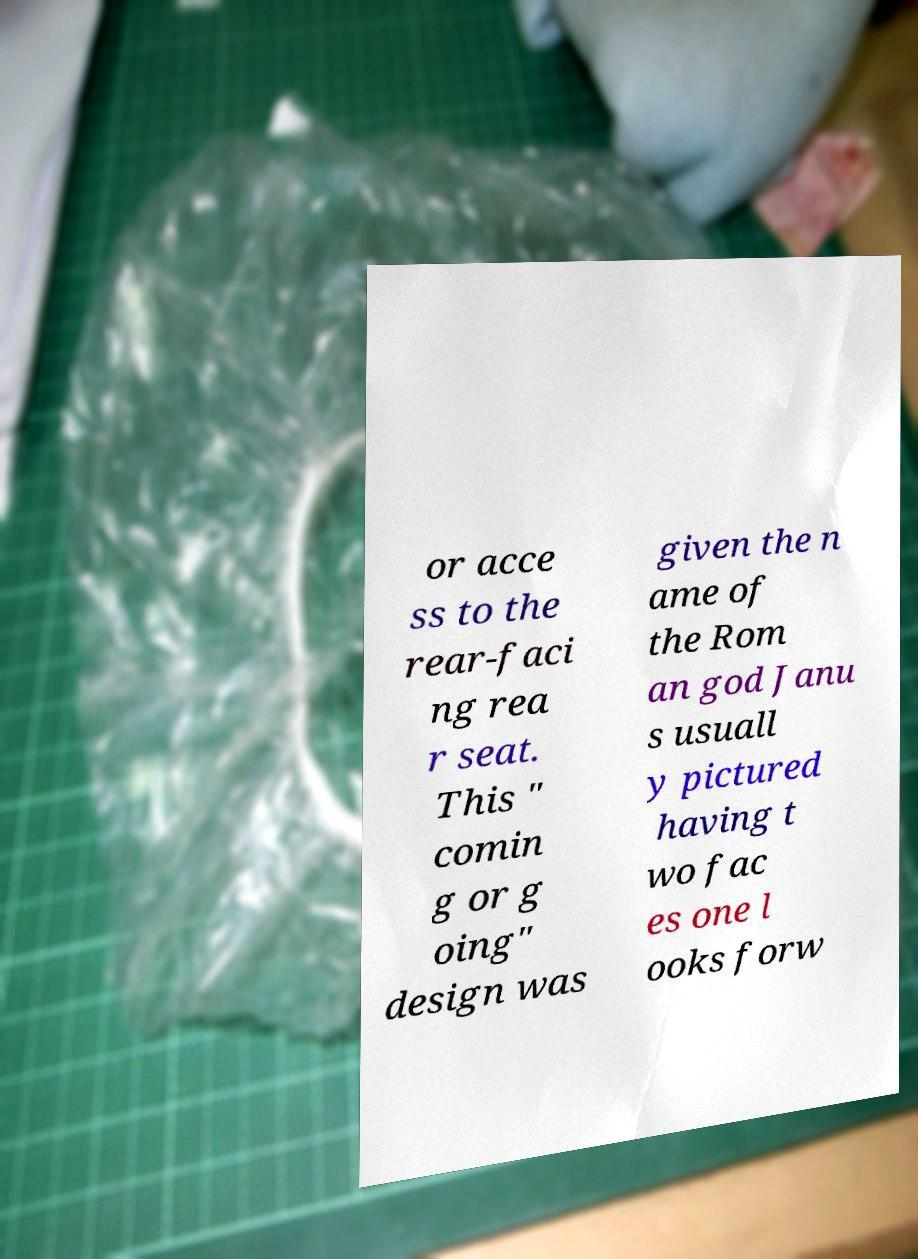Please read and relay the text visible in this image. What does it say? or acce ss to the rear-faci ng rea r seat. This " comin g or g oing" design was given the n ame of the Rom an god Janu s usuall y pictured having t wo fac es one l ooks forw 